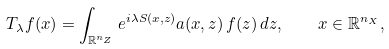Convert formula to latex. <formula><loc_0><loc_0><loc_500><loc_500>T _ { \lambda } f ( x ) = \int _ { \mathbb { R } ^ { n _ { Z } } } e ^ { i \lambda S ( x , z ) } a ( x , z ) \, f ( z ) \, d z , \quad x \in \mathbb { R } ^ { n _ { X } } ,</formula> 